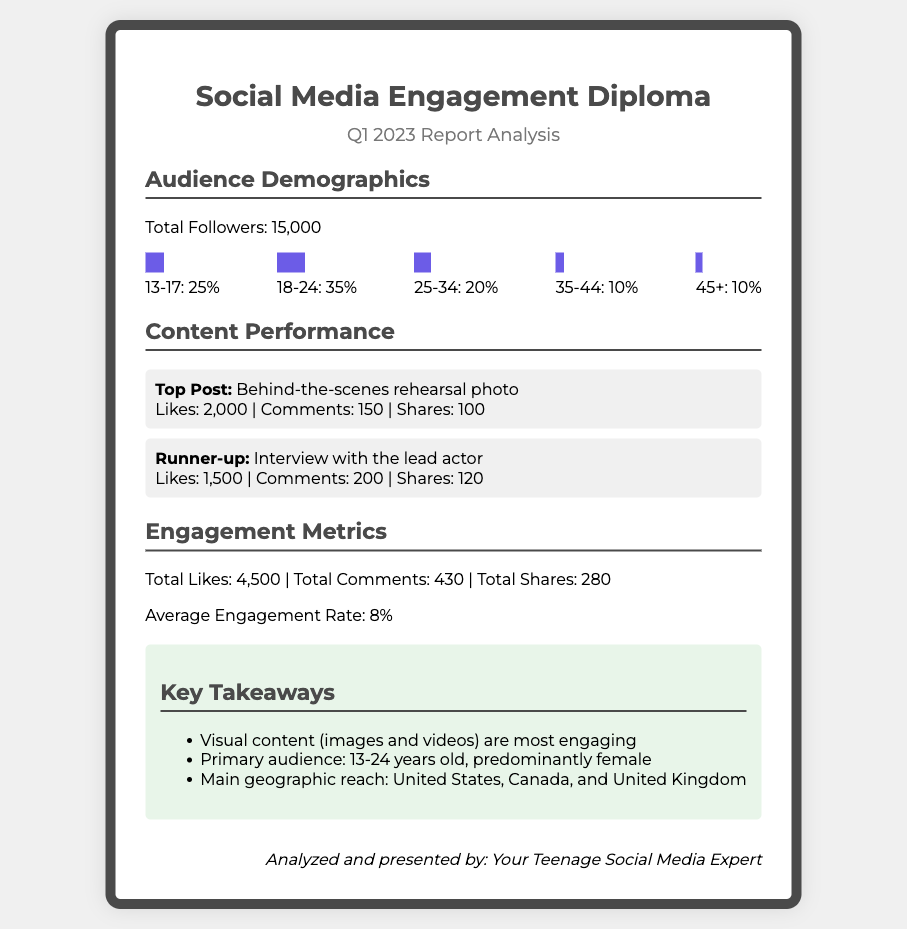What is the total number of followers? The total followers are mentioned explicitly in the document as "Total Followers: 15,000."
Answer: 15,000 What is the percentage of the audience aged 18-24? This percentage can be found in the demographics section, listed as "18-24: 35%."
Answer: 35% What was the top post in terms of engagement? The document specifies the top post as "Behind-the-scenes rehearsal photo."
Answer: Behind-the-scenes rehearsal photo How many likes did the runner-up post receive? This information is provided under the performance of the runner-up post, stating "Likes: 1,500."
Answer: 1,500 What is the average engagement rate? The average engagement rate is explicitly stated in the engagement metrics section as "8%."
Answer: 8% Which geographic regions make up the main audience? The key takeaways mention the main geographic reach as "United States, Canada, and United Kingdom."
Answer: United States, Canada, and United Kingdom What type of content is most engaging according to the report? The key takeaways indicate that "Visual content (images and videos) are most engaging."
Answer: Visual content What is the total number of comments? Total comments are summarized in the engagement metrics section as "Total Comments: 430."
Answer: 430 Who analyzed and presented the report? The document concludes with the signature stating it was analyzed and presented by "Your Teenage Social Media Expert."
Answer: Your Teenage Social Media Expert 